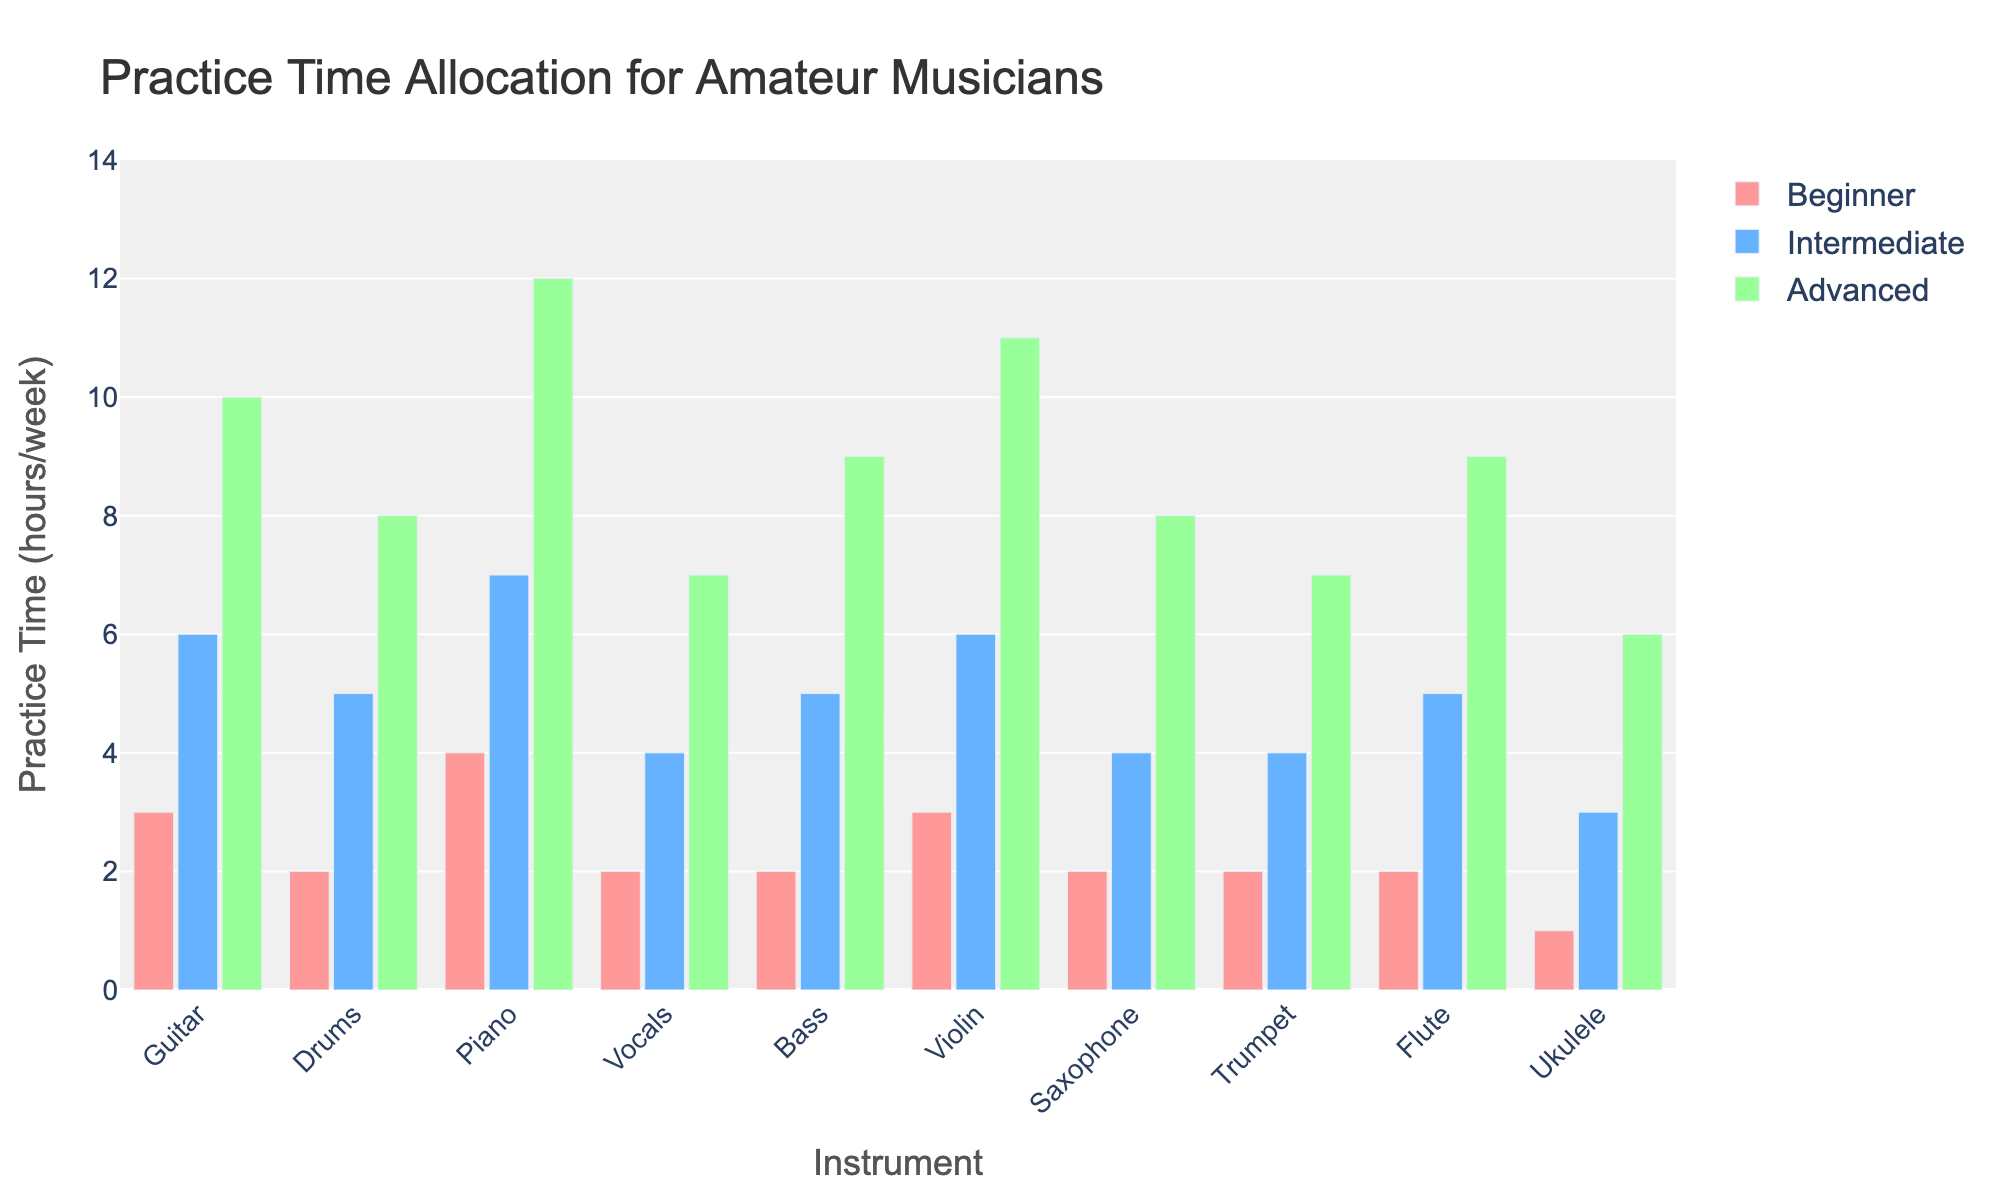what instrument has the highest practice time for advanced musicians? To determine this, look at the green bars representing the advanced proficiency levels and identify the highest bar. The piano shows the highest practice time for advanced musicians.
Answer: Piano Which proficiency level has the least practice time for the flute? Check the bars for the flute and identify the smallest bar among green (advanced), blue (intermediate), and red (beginner). The beginner level has the least practice time for the flute.
Answer: Beginner How much more time do advanced drummers practice compared to beginner drummers? Identify the bars for the drums. For beginner drummers, the practice time is 2 hours. For advanced drummers, it is 8 hours. Subtract the beginner hours from the advanced hours (8 - 2 = 6).
Answer: 6 hours Which instrument sees the biggest increase in practice time from beginner to intermediate levels? Look at the difference between red and blue bars for each instrument. Calculate the differences: Guitar (6-3=3), Drums (5-2=3), Piano (7-4=3), Vocals (4-2=2), Bass (5-2=3), Violin (6-3=3), Saxophone (4-2=2), Trumpet (4-2=2), Flute (5-2=3), Ukulele (3-1=2). No instrument has a larger increase than 3 hours; several instruments have the same largest increase of 3 hours (Guitar, Drums, Piano, Bass, Violin, and Flute).
Answer: Multiple (Guitar, Drums, Piano, Bass, Violin, Flute) What is the average practice time for intermediate musicians across all instruments? Sum the intermediate times for all instruments and divide by the number of instruments: (6+5+7+4+5+6+4+4+5+3)/10 = 49/10 = 4.9.
Answer: 4.9 hours Which instrument's practice time differences remain consistent (same hours) between all proficiency levels? Calculate the differences between Beginner-Intermediate and Intermediate-Advanced for each instrument: Guitar (3, 4), Drums (3, 3), Piano (3, 5), Vocals (2, 3), Bass (3, 4), Violin (3, 5), Saxophone (2, 4), Trumpet (2, 3), Flute (3, 4), Ukulele (2, 3). Only the drums have consistent practice time differences between all levels (3 hours each).
Answer: Drums What is the total practice time for all proficiency levels combined for the violin? Sum the practice times of the violin across all proficiency levels: 3 (Beginner) + 6 (Intermediate) + 11 (Advanced) = 20 hours.
Answer: 20 hours Which instruments have a higher practice time for intermediate musicians compared to advanced ukulele players? Advanced ukulele practice time is 6 hours. Compare this to the intermediate times: Guitar (6), Drums (5), Piano (7), Vocals (4), Bass (5), Violin (6), Saxophone (4), Trumpet (4), Flute (5). The piano has a higher practice time for intermediate musicians compared to advanced ukulele players.
Answer: Piano 